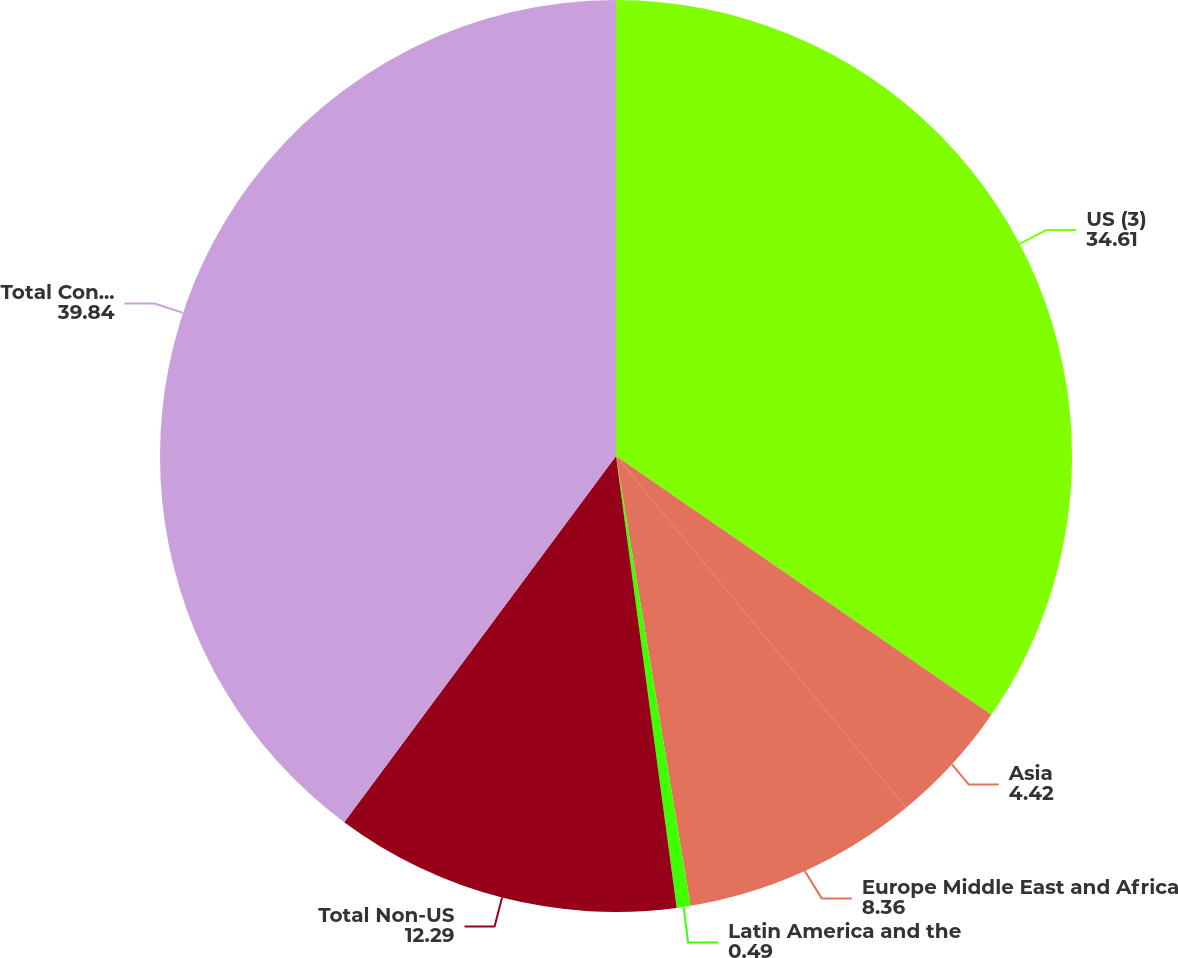<chart> <loc_0><loc_0><loc_500><loc_500><pie_chart><fcel>US (3)<fcel>Asia<fcel>Europe Middle East and Africa<fcel>Latin America and the<fcel>Total Non-US<fcel>Total Consolidated<nl><fcel>34.61%<fcel>4.42%<fcel>8.36%<fcel>0.49%<fcel>12.29%<fcel>39.84%<nl></chart> 